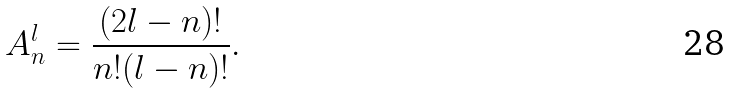Convert formula to latex. <formula><loc_0><loc_0><loc_500><loc_500>A _ { n } ^ { l } = \frac { ( 2 l - n ) ! } { n ! ( l - n ) ! } .</formula> 